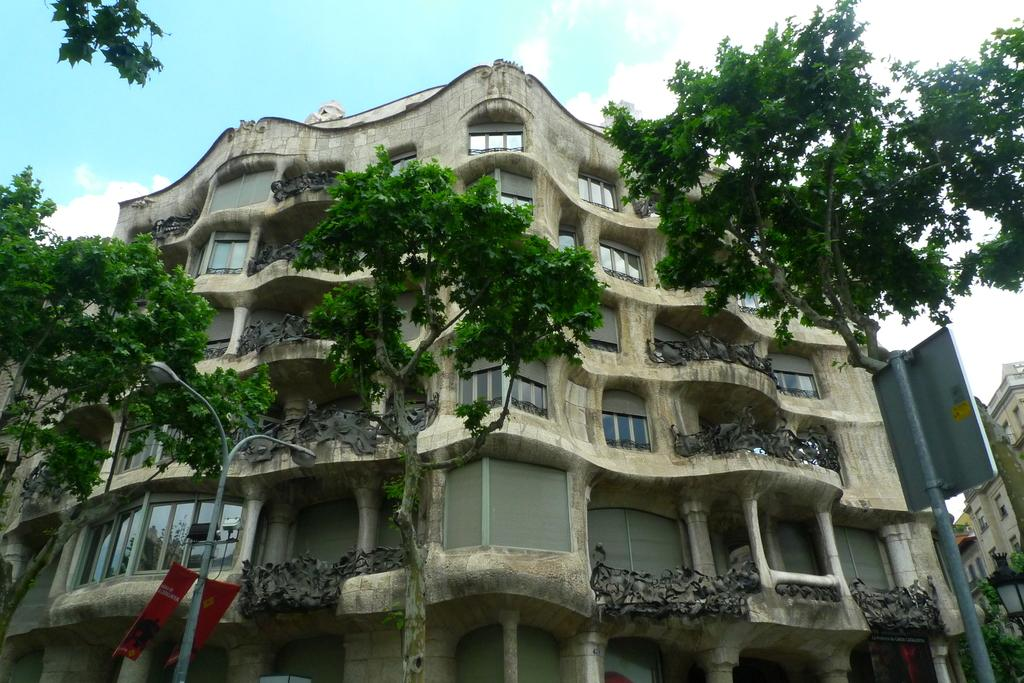What type of natural elements can be seen in the image? There are trees in the image. What man-made structures are present in the image? There are poles in the image. What can be seen in the background of the image? There are buildings in the background of the image. Can you see any powder on the trees in the image? There is no mention of powder in the image, so it cannot be determined if there is any powder on the trees. Is there an ocean visible in the image? There is no mention of an ocean in the image, so it cannot be determined if there is an ocean visible. 